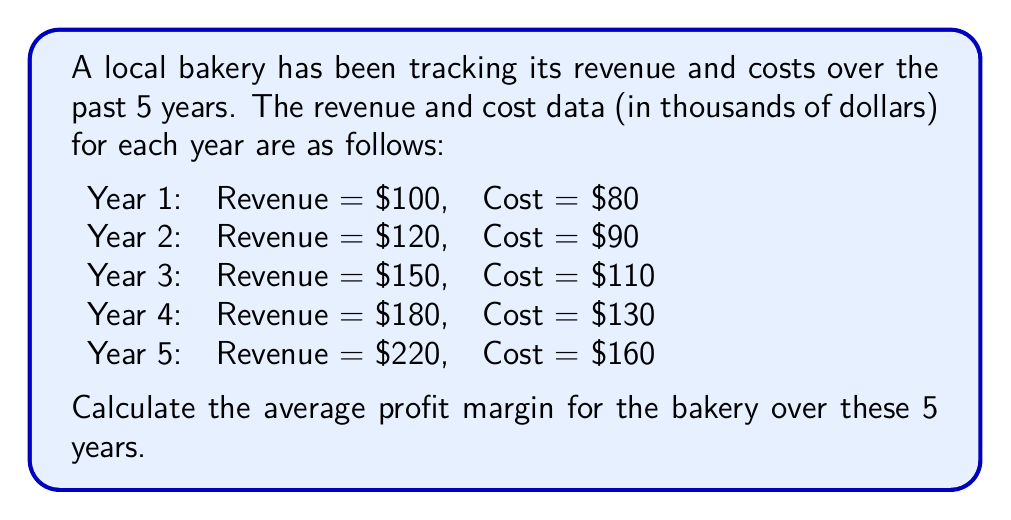Give your solution to this math problem. To solve this problem, we'll follow these steps:

1. Calculate the profit for each year:
   Profit = Revenue - Cost

   Year 1: $100 - $80 = $20
   Year 2: $120 - $90 = $30
   Year 3: $150 - $110 = $40
   Year 4: $180 - $130 = $50
   Year 5: $220 - $160 = $60

2. Calculate the profit margin for each year:
   Profit Margin = (Profit / Revenue) × 100%

   Year 1: $(20 / 100) × 100\% = 20\%$
   Year 2: $(30 / 120) × 100\% = 25\%$
   Year 3: $(40 / 150) × 100\% ≈ 26.67\%$
   Year 4: $(50 / 180) × 100\% ≈ 27.78\%$
   Year 5: $(60 / 220) × 100\% ≈ 27.27\%$

3. Calculate the average profit margin:
   Average Profit Margin = (Sum of all profit margins) / Number of years

   $\frac{20\% + 25\% + 26.67\% + 27.78\% + 27.27\%}{5} ≈ 25.34\%$

Therefore, the average profit margin for the bakery over these 5 years is approximately 25.34%.
Answer: 25.34% 